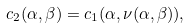<formula> <loc_0><loc_0><loc_500><loc_500>c _ { 2 } ( \alpha , \beta ) = c _ { 1 } ( \alpha , \nu ( \alpha , \beta ) ) ,</formula> 